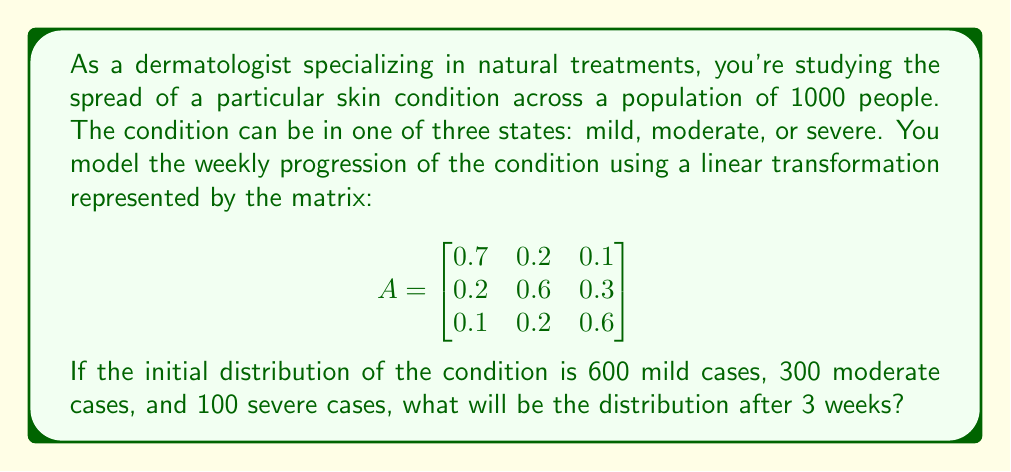Solve this math problem. To solve this problem, we need to use matrix multiplication to apply the linear transformation repeatedly. Let's break it down step by step:

1. First, let's represent the initial distribution as a column vector:

   $$v_0 = \begin{bmatrix}
   600 \\
   300 \\
   100
   \end{bmatrix}$$

2. To find the distribution after one week, we multiply A by v_0:

   $$v_1 = Av_0 = \begin{bmatrix}
   0.7 & 0.2 & 0.1 \\
   0.2 & 0.6 & 0.3 \\
   0.1 & 0.2 & 0.6
   \end{bmatrix} \begin{bmatrix}
   600 \\
   300 \\
   100
   \end{bmatrix} = \begin{bmatrix}
   510 \\
   330 \\
   160
   \end{bmatrix}$$

3. For the second week, we multiply A by v_1:

   $$v_2 = Av_1 = \begin{bmatrix}
   0.7 & 0.2 & 0.1 \\
   0.2 & 0.6 & 0.3 \\
   0.1 & 0.2 & 0.6
   \end{bmatrix} \begin{bmatrix}
   510 \\
   330 \\
   160
   \end{bmatrix} = \begin{bmatrix}
   453 \\
   348 \\
   199
   \end{bmatrix}$$

4. For the third week, we multiply A by v_2:

   $$v_3 = Av_2 = \begin{bmatrix}
   0.7 & 0.2 & 0.1 \\
   0.2 & 0.6 & 0.3 \\
   0.1 & 0.2 & 0.6
   \end{bmatrix} \begin{bmatrix}
   453 \\
   348 \\
   199
   \end{bmatrix} = \begin{bmatrix}
   417.1 \\
   358.5 \\
   224.4
   \end{bmatrix}$$

5. Rounding to the nearest whole number (as we can't have fractional people), we get the final distribution after 3 weeks.
Answer: After 3 weeks, the distribution of the skin condition will be approximately:
417 mild cases, 359 moderate cases, and 224 severe cases. 